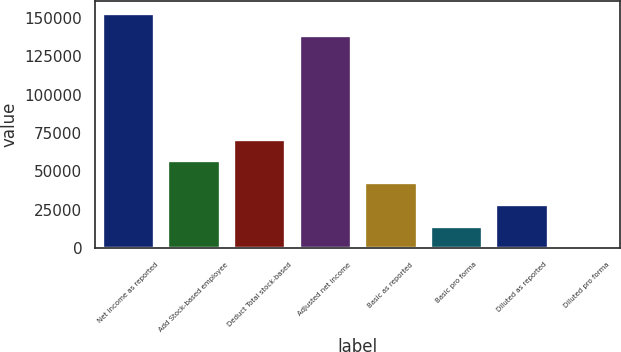Convert chart to OTSL. <chart><loc_0><loc_0><loc_500><loc_500><bar_chart><fcel>Net income as reported<fcel>Add Stock-based employee<fcel>Deduct Total stock-based<fcel>Adjusted net income<fcel>Basic as reported<fcel>Basic pro forma<fcel>Diluted as reported<fcel>Diluted pro forma<nl><fcel>153127<fcel>57102.5<fcel>71377.9<fcel>138852<fcel>42827.1<fcel>14276.2<fcel>28551.7<fcel>0.83<nl></chart> 